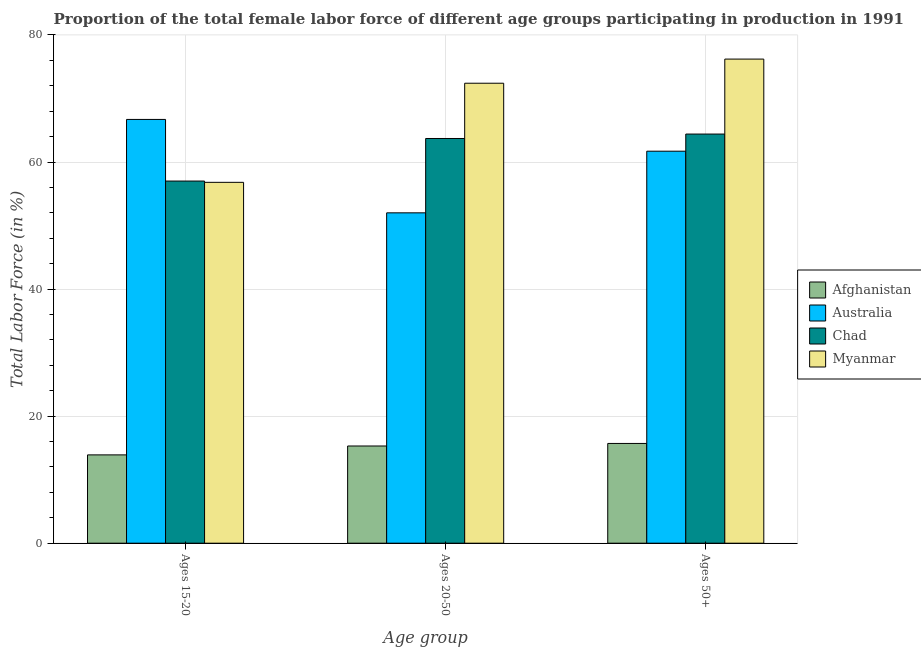How many groups of bars are there?
Offer a very short reply. 3. Are the number of bars per tick equal to the number of legend labels?
Offer a terse response. Yes. Are the number of bars on each tick of the X-axis equal?
Ensure brevity in your answer.  Yes. How many bars are there on the 2nd tick from the left?
Your response must be concise. 4. How many bars are there on the 1st tick from the right?
Provide a succinct answer. 4. What is the label of the 1st group of bars from the left?
Give a very brief answer. Ages 15-20. What is the percentage of female labor force above age 50 in Australia?
Give a very brief answer. 61.7. Across all countries, what is the maximum percentage of female labor force above age 50?
Keep it short and to the point. 76.2. Across all countries, what is the minimum percentage of female labor force above age 50?
Keep it short and to the point. 15.7. In which country was the percentage of female labor force within the age group 20-50 minimum?
Ensure brevity in your answer.  Afghanistan. What is the total percentage of female labor force above age 50 in the graph?
Your response must be concise. 218. What is the difference between the percentage of female labor force above age 50 in Chad and that in Myanmar?
Your answer should be very brief. -11.8. What is the difference between the percentage of female labor force above age 50 in Afghanistan and the percentage of female labor force within the age group 15-20 in Australia?
Ensure brevity in your answer.  -51. What is the average percentage of female labor force above age 50 per country?
Offer a very short reply. 54.5. What is the difference between the percentage of female labor force within the age group 15-20 and percentage of female labor force above age 50 in Afghanistan?
Provide a short and direct response. -1.8. In how many countries, is the percentage of female labor force within the age group 20-50 greater than 68 %?
Offer a very short reply. 1. What is the ratio of the percentage of female labor force within the age group 15-20 in Myanmar to that in Afghanistan?
Make the answer very short. 4.09. What is the difference between the highest and the second highest percentage of female labor force within the age group 15-20?
Ensure brevity in your answer.  9.7. What is the difference between the highest and the lowest percentage of female labor force above age 50?
Offer a very short reply. 60.5. Is the sum of the percentage of female labor force above age 50 in Chad and Afghanistan greater than the maximum percentage of female labor force within the age group 20-50 across all countries?
Your answer should be very brief. Yes. What does the 2nd bar from the left in Ages 50+ represents?
Your response must be concise. Australia. What does the 2nd bar from the right in Ages 20-50 represents?
Offer a very short reply. Chad. Is it the case that in every country, the sum of the percentage of female labor force within the age group 15-20 and percentage of female labor force within the age group 20-50 is greater than the percentage of female labor force above age 50?
Your response must be concise. Yes. How many bars are there?
Provide a short and direct response. 12. Are all the bars in the graph horizontal?
Ensure brevity in your answer.  No. What is the difference between two consecutive major ticks on the Y-axis?
Ensure brevity in your answer.  20. Are the values on the major ticks of Y-axis written in scientific E-notation?
Provide a succinct answer. No. Does the graph contain any zero values?
Give a very brief answer. No. Does the graph contain grids?
Your answer should be compact. Yes. How many legend labels are there?
Your answer should be compact. 4. What is the title of the graph?
Ensure brevity in your answer.  Proportion of the total female labor force of different age groups participating in production in 1991. What is the label or title of the X-axis?
Ensure brevity in your answer.  Age group. What is the label or title of the Y-axis?
Provide a succinct answer. Total Labor Force (in %). What is the Total Labor Force (in %) in Afghanistan in Ages 15-20?
Provide a succinct answer. 13.9. What is the Total Labor Force (in %) of Australia in Ages 15-20?
Give a very brief answer. 66.7. What is the Total Labor Force (in %) of Myanmar in Ages 15-20?
Give a very brief answer. 56.8. What is the Total Labor Force (in %) of Afghanistan in Ages 20-50?
Your answer should be compact. 15.3. What is the Total Labor Force (in %) in Chad in Ages 20-50?
Give a very brief answer. 63.7. What is the Total Labor Force (in %) of Myanmar in Ages 20-50?
Give a very brief answer. 72.4. What is the Total Labor Force (in %) in Afghanistan in Ages 50+?
Your answer should be very brief. 15.7. What is the Total Labor Force (in %) of Australia in Ages 50+?
Your response must be concise. 61.7. What is the Total Labor Force (in %) in Chad in Ages 50+?
Make the answer very short. 64.4. What is the Total Labor Force (in %) of Myanmar in Ages 50+?
Give a very brief answer. 76.2. Across all Age group, what is the maximum Total Labor Force (in %) of Afghanistan?
Provide a succinct answer. 15.7. Across all Age group, what is the maximum Total Labor Force (in %) of Australia?
Ensure brevity in your answer.  66.7. Across all Age group, what is the maximum Total Labor Force (in %) of Chad?
Give a very brief answer. 64.4. Across all Age group, what is the maximum Total Labor Force (in %) in Myanmar?
Keep it short and to the point. 76.2. Across all Age group, what is the minimum Total Labor Force (in %) in Afghanistan?
Your answer should be compact. 13.9. Across all Age group, what is the minimum Total Labor Force (in %) in Chad?
Keep it short and to the point. 57. Across all Age group, what is the minimum Total Labor Force (in %) in Myanmar?
Make the answer very short. 56.8. What is the total Total Labor Force (in %) of Afghanistan in the graph?
Offer a terse response. 44.9. What is the total Total Labor Force (in %) in Australia in the graph?
Keep it short and to the point. 180.4. What is the total Total Labor Force (in %) of Chad in the graph?
Keep it short and to the point. 185.1. What is the total Total Labor Force (in %) in Myanmar in the graph?
Your answer should be very brief. 205.4. What is the difference between the Total Labor Force (in %) in Afghanistan in Ages 15-20 and that in Ages 20-50?
Make the answer very short. -1.4. What is the difference between the Total Labor Force (in %) in Chad in Ages 15-20 and that in Ages 20-50?
Your response must be concise. -6.7. What is the difference between the Total Labor Force (in %) in Myanmar in Ages 15-20 and that in Ages 20-50?
Your answer should be very brief. -15.6. What is the difference between the Total Labor Force (in %) in Australia in Ages 15-20 and that in Ages 50+?
Your answer should be compact. 5. What is the difference between the Total Labor Force (in %) of Myanmar in Ages 15-20 and that in Ages 50+?
Offer a very short reply. -19.4. What is the difference between the Total Labor Force (in %) of Afghanistan in Ages 20-50 and that in Ages 50+?
Your response must be concise. -0.4. What is the difference between the Total Labor Force (in %) in Myanmar in Ages 20-50 and that in Ages 50+?
Give a very brief answer. -3.8. What is the difference between the Total Labor Force (in %) of Afghanistan in Ages 15-20 and the Total Labor Force (in %) of Australia in Ages 20-50?
Provide a short and direct response. -38.1. What is the difference between the Total Labor Force (in %) of Afghanistan in Ages 15-20 and the Total Labor Force (in %) of Chad in Ages 20-50?
Make the answer very short. -49.8. What is the difference between the Total Labor Force (in %) of Afghanistan in Ages 15-20 and the Total Labor Force (in %) of Myanmar in Ages 20-50?
Your answer should be compact. -58.5. What is the difference between the Total Labor Force (in %) of Australia in Ages 15-20 and the Total Labor Force (in %) of Myanmar in Ages 20-50?
Keep it short and to the point. -5.7. What is the difference between the Total Labor Force (in %) of Chad in Ages 15-20 and the Total Labor Force (in %) of Myanmar in Ages 20-50?
Your answer should be very brief. -15.4. What is the difference between the Total Labor Force (in %) of Afghanistan in Ages 15-20 and the Total Labor Force (in %) of Australia in Ages 50+?
Offer a very short reply. -47.8. What is the difference between the Total Labor Force (in %) in Afghanistan in Ages 15-20 and the Total Labor Force (in %) in Chad in Ages 50+?
Ensure brevity in your answer.  -50.5. What is the difference between the Total Labor Force (in %) of Afghanistan in Ages 15-20 and the Total Labor Force (in %) of Myanmar in Ages 50+?
Offer a very short reply. -62.3. What is the difference between the Total Labor Force (in %) of Australia in Ages 15-20 and the Total Labor Force (in %) of Chad in Ages 50+?
Provide a succinct answer. 2.3. What is the difference between the Total Labor Force (in %) in Australia in Ages 15-20 and the Total Labor Force (in %) in Myanmar in Ages 50+?
Offer a terse response. -9.5. What is the difference between the Total Labor Force (in %) of Chad in Ages 15-20 and the Total Labor Force (in %) of Myanmar in Ages 50+?
Provide a succinct answer. -19.2. What is the difference between the Total Labor Force (in %) of Afghanistan in Ages 20-50 and the Total Labor Force (in %) of Australia in Ages 50+?
Ensure brevity in your answer.  -46.4. What is the difference between the Total Labor Force (in %) of Afghanistan in Ages 20-50 and the Total Labor Force (in %) of Chad in Ages 50+?
Your answer should be very brief. -49.1. What is the difference between the Total Labor Force (in %) in Afghanistan in Ages 20-50 and the Total Labor Force (in %) in Myanmar in Ages 50+?
Offer a terse response. -60.9. What is the difference between the Total Labor Force (in %) of Australia in Ages 20-50 and the Total Labor Force (in %) of Chad in Ages 50+?
Provide a short and direct response. -12.4. What is the difference between the Total Labor Force (in %) of Australia in Ages 20-50 and the Total Labor Force (in %) of Myanmar in Ages 50+?
Your answer should be very brief. -24.2. What is the average Total Labor Force (in %) of Afghanistan per Age group?
Your answer should be very brief. 14.97. What is the average Total Labor Force (in %) of Australia per Age group?
Offer a very short reply. 60.13. What is the average Total Labor Force (in %) in Chad per Age group?
Offer a terse response. 61.7. What is the average Total Labor Force (in %) in Myanmar per Age group?
Provide a succinct answer. 68.47. What is the difference between the Total Labor Force (in %) of Afghanistan and Total Labor Force (in %) of Australia in Ages 15-20?
Give a very brief answer. -52.8. What is the difference between the Total Labor Force (in %) in Afghanistan and Total Labor Force (in %) in Chad in Ages 15-20?
Give a very brief answer. -43.1. What is the difference between the Total Labor Force (in %) in Afghanistan and Total Labor Force (in %) in Myanmar in Ages 15-20?
Keep it short and to the point. -42.9. What is the difference between the Total Labor Force (in %) of Australia and Total Labor Force (in %) of Chad in Ages 15-20?
Keep it short and to the point. 9.7. What is the difference between the Total Labor Force (in %) of Chad and Total Labor Force (in %) of Myanmar in Ages 15-20?
Offer a terse response. 0.2. What is the difference between the Total Labor Force (in %) of Afghanistan and Total Labor Force (in %) of Australia in Ages 20-50?
Your response must be concise. -36.7. What is the difference between the Total Labor Force (in %) of Afghanistan and Total Labor Force (in %) of Chad in Ages 20-50?
Ensure brevity in your answer.  -48.4. What is the difference between the Total Labor Force (in %) of Afghanistan and Total Labor Force (in %) of Myanmar in Ages 20-50?
Provide a succinct answer. -57.1. What is the difference between the Total Labor Force (in %) in Australia and Total Labor Force (in %) in Chad in Ages 20-50?
Offer a terse response. -11.7. What is the difference between the Total Labor Force (in %) of Australia and Total Labor Force (in %) of Myanmar in Ages 20-50?
Your response must be concise. -20.4. What is the difference between the Total Labor Force (in %) of Afghanistan and Total Labor Force (in %) of Australia in Ages 50+?
Ensure brevity in your answer.  -46. What is the difference between the Total Labor Force (in %) of Afghanistan and Total Labor Force (in %) of Chad in Ages 50+?
Provide a succinct answer. -48.7. What is the difference between the Total Labor Force (in %) in Afghanistan and Total Labor Force (in %) in Myanmar in Ages 50+?
Your answer should be compact. -60.5. What is the difference between the Total Labor Force (in %) of Australia and Total Labor Force (in %) of Chad in Ages 50+?
Ensure brevity in your answer.  -2.7. What is the difference between the Total Labor Force (in %) in Chad and Total Labor Force (in %) in Myanmar in Ages 50+?
Offer a very short reply. -11.8. What is the ratio of the Total Labor Force (in %) of Afghanistan in Ages 15-20 to that in Ages 20-50?
Your answer should be compact. 0.91. What is the ratio of the Total Labor Force (in %) of Australia in Ages 15-20 to that in Ages 20-50?
Your response must be concise. 1.28. What is the ratio of the Total Labor Force (in %) of Chad in Ages 15-20 to that in Ages 20-50?
Provide a succinct answer. 0.89. What is the ratio of the Total Labor Force (in %) in Myanmar in Ages 15-20 to that in Ages 20-50?
Provide a succinct answer. 0.78. What is the ratio of the Total Labor Force (in %) in Afghanistan in Ages 15-20 to that in Ages 50+?
Keep it short and to the point. 0.89. What is the ratio of the Total Labor Force (in %) in Australia in Ages 15-20 to that in Ages 50+?
Keep it short and to the point. 1.08. What is the ratio of the Total Labor Force (in %) in Chad in Ages 15-20 to that in Ages 50+?
Give a very brief answer. 0.89. What is the ratio of the Total Labor Force (in %) in Myanmar in Ages 15-20 to that in Ages 50+?
Your answer should be very brief. 0.75. What is the ratio of the Total Labor Force (in %) of Afghanistan in Ages 20-50 to that in Ages 50+?
Your answer should be compact. 0.97. What is the ratio of the Total Labor Force (in %) in Australia in Ages 20-50 to that in Ages 50+?
Your answer should be compact. 0.84. What is the ratio of the Total Labor Force (in %) of Myanmar in Ages 20-50 to that in Ages 50+?
Ensure brevity in your answer.  0.95. What is the difference between the highest and the second highest Total Labor Force (in %) in Afghanistan?
Give a very brief answer. 0.4. What is the difference between the highest and the second highest Total Labor Force (in %) of Australia?
Provide a succinct answer. 5. What is the difference between the highest and the second highest Total Labor Force (in %) of Chad?
Provide a short and direct response. 0.7. What is the difference between the highest and the lowest Total Labor Force (in %) in Afghanistan?
Keep it short and to the point. 1.8. What is the difference between the highest and the lowest Total Labor Force (in %) in Australia?
Keep it short and to the point. 14.7. What is the difference between the highest and the lowest Total Labor Force (in %) of Myanmar?
Offer a terse response. 19.4. 